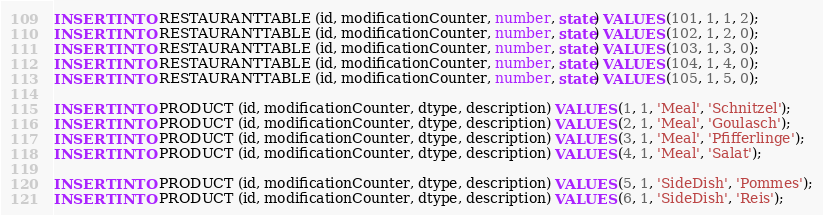Convert code to text. <code><loc_0><loc_0><loc_500><loc_500><_SQL_>INSERT INTO RESTAURANTTABLE (id, modificationCounter, number, state) VALUES (101, 1, 1, 2);
INSERT INTO RESTAURANTTABLE (id, modificationCounter, number, state) VALUES (102, 1, 2, 0);
INSERT INTO RESTAURANTTABLE (id, modificationCounter, number, state) VALUES (103, 1, 3, 0);
INSERT INTO RESTAURANTTABLE (id, modificationCounter, number, state) VALUES (104, 1, 4, 0);
INSERT INTO RESTAURANTTABLE (id, modificationCounter, number, state) VALUES (105, 1, 5, 0);

INSERT INTO PRODUCT (id, modificationCounter, dtype, description) VALUES (1, 1, 'Meal', 'Schnitzel');
INSERT INTO PRODUCT (id, modificationCounter, dtype, description) VALUES (2, 1, 'Meal', 'Goulasch');
INSERT INTO PRODUCT (id, modificationCounter, dtype, description) VALUES (3, 1, 'Meal', 'Pfifferlinge');
INSERT INTO PRODUCT (id, modificationCounter, dtype, description) VALUES (4, 1, 'Meal', 'Salat');

INSERT INTO PRODUCT (id, modificationCounter, dtype, description) VALUES (5, 1, 'SideDish', 'Pommes');
INSERT INTO PRODUCT (id, modificationCounter, dtype, description) VALUES (6, 1, 'SideDish', 'Reis');</code> 